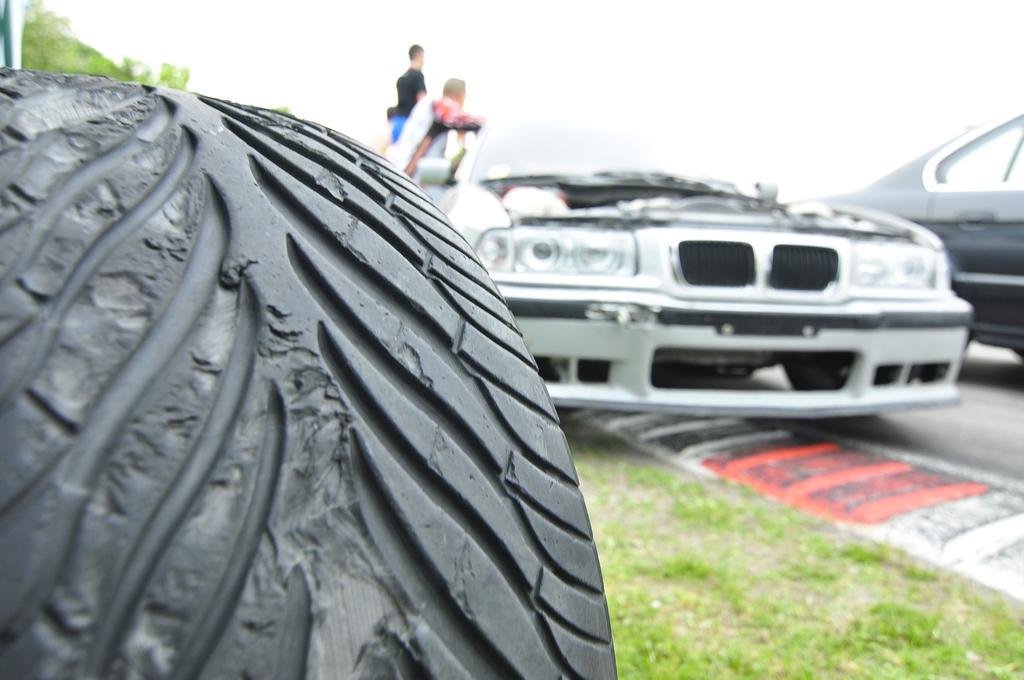Please provide a concise description of this image. On the left side of the image we can see Tyre. On the right side of the image we can see cars on the road. In the background we can see persons, tree and sky. 